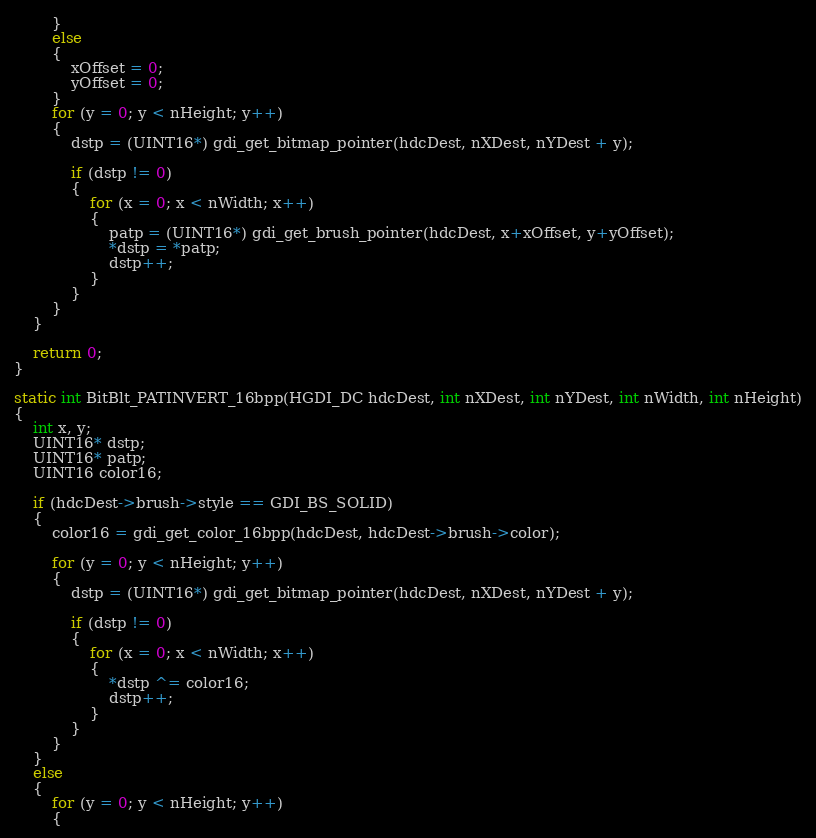Convert code to text. <code><loc_0><loc_0><loc_500><loc_500><_C_>		}
		else
		{
			xOffset = 0;
			yOffset = 0;
		}
		for (y = 0; y < nHeight; y++)
		{
			dstp = (UINT16*) gdi_get_bitmap_pointer(hdcDest, nXDest, nYDest + y);

			if (dstp != 0)
			{
				for (x = 0; x < nWidth; x++)
				{
					patp = (UINT16*) gdi_get_brush_pointer(hdcDest, x+xOffset, y+yOffset);
					*dstp = *patp;
					dstp++;
				}
			}
		}
	}

	return 0;
}

static int BitBlt_PATINVERT_16bpp(HGDI_DC hdcDest, int nXDest, int nYDest, int nWidth, int nHeight)
{
	int x, y;
	UINT16* dstp;
	UINT16* patp;
	UINT16 color16;

	if (hdcDest->brush->style == GDI_BS_SOLID)
	{
		color16 = gdi_get_color_16bpp(hdcDest, hdcDest->brush->color);

		for (y = 0; y < nHeight; y++)
		{
			dstp = (UINT16*) gdi_get_bitmap_pointer(hdcDest, nXDest, nYDest + y);

			if (dstp != 0)
			{
				for (x = 0; x < nWidth; x++)
				{
					*dstp ^= color16;
					dstp++;
				}
			}
		}
	}
	else
	{
		for (y = 0; y < nHeight; y++)
		{</code> 